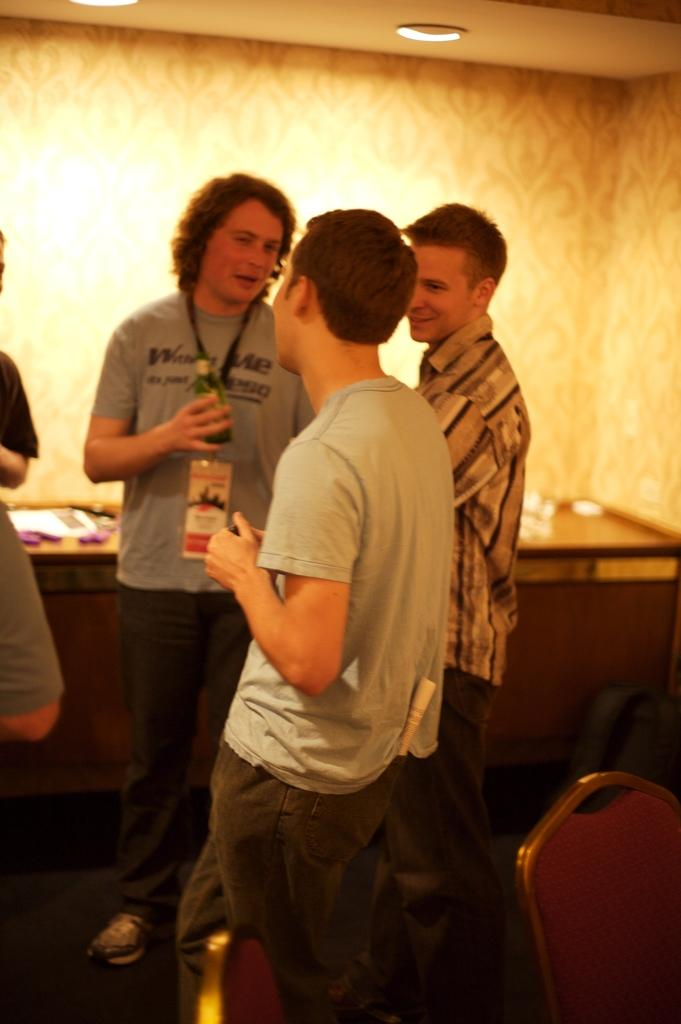How many people are in the image? There are three men in the image. What are the men doing in the image? The men are standing and talking. What are the men wearing in the image? The men are wearing t-shirts. What can be seen in the background of the image? There are ceiling lights visible in the image. What type of cough can be heard from one of the men in the image? There is no indication of any coughing in the image; the men are simply talking. How many oranges are visible in the image? There are no oranges present in the image. 